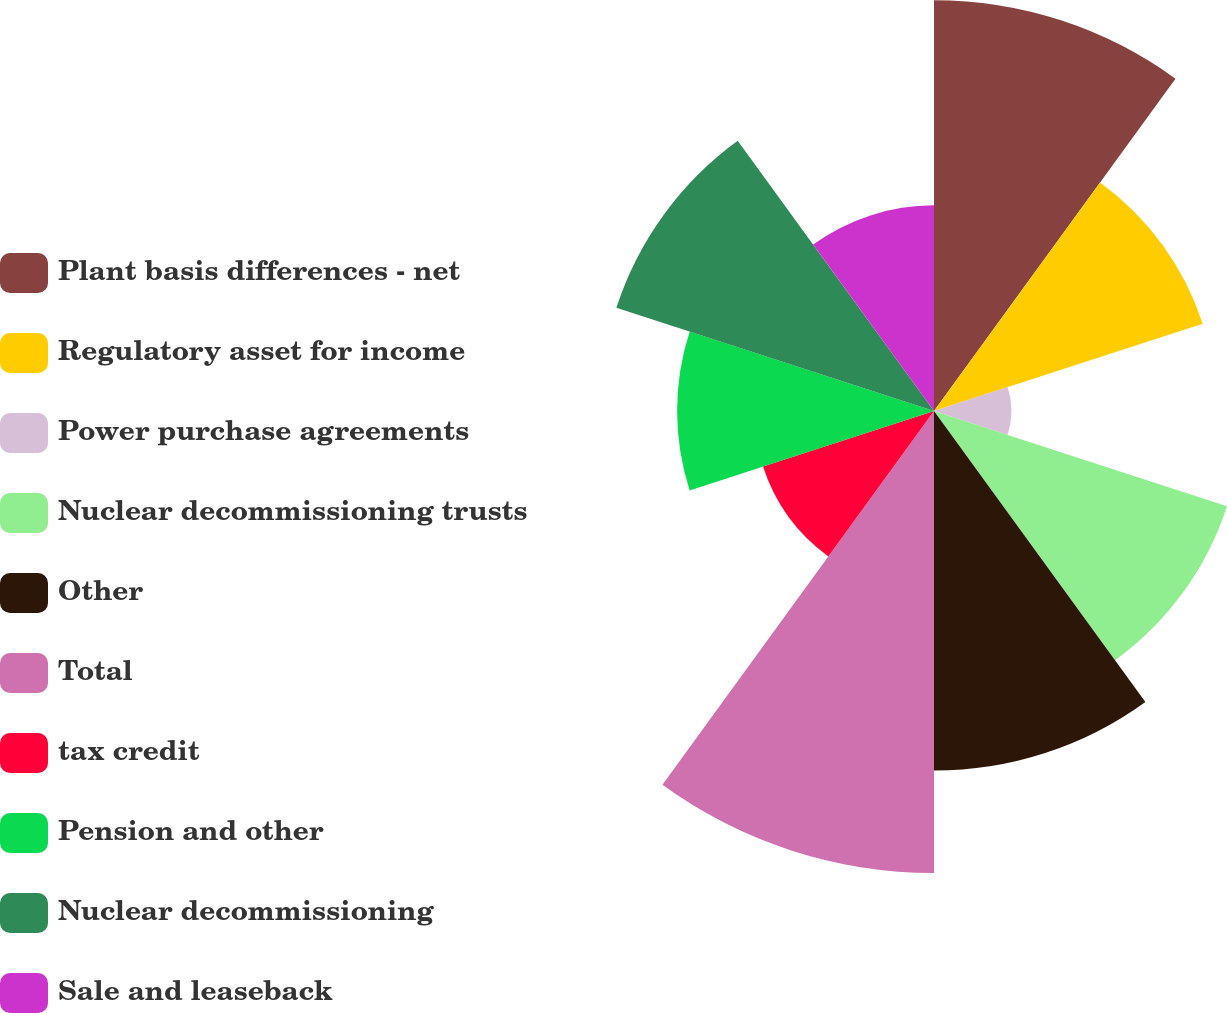<chart> <loc_0><loc_0><loc_500><loc_500><pie_chart><fcel>Plant basis differences - net<fcel>Regulatory asset for income<fcel>Power purchase agreements<fcel>Nuclear decommissioning trusts<fcel>Other<fcel>Total<fcel>tax credit<fcel>Pension and other<fcel>Nuclear decommissioning<fcel>Sale and leaseback<nl><fcel>14.28%<fcel>9.82%<fcel>2.69%<fcel>10.71%<fcel>12.5%<fcel>16.06%<fcel>6.25%<fcel>8.93%<fcel>11.61%<fcel>7.15%<nl></chart> 